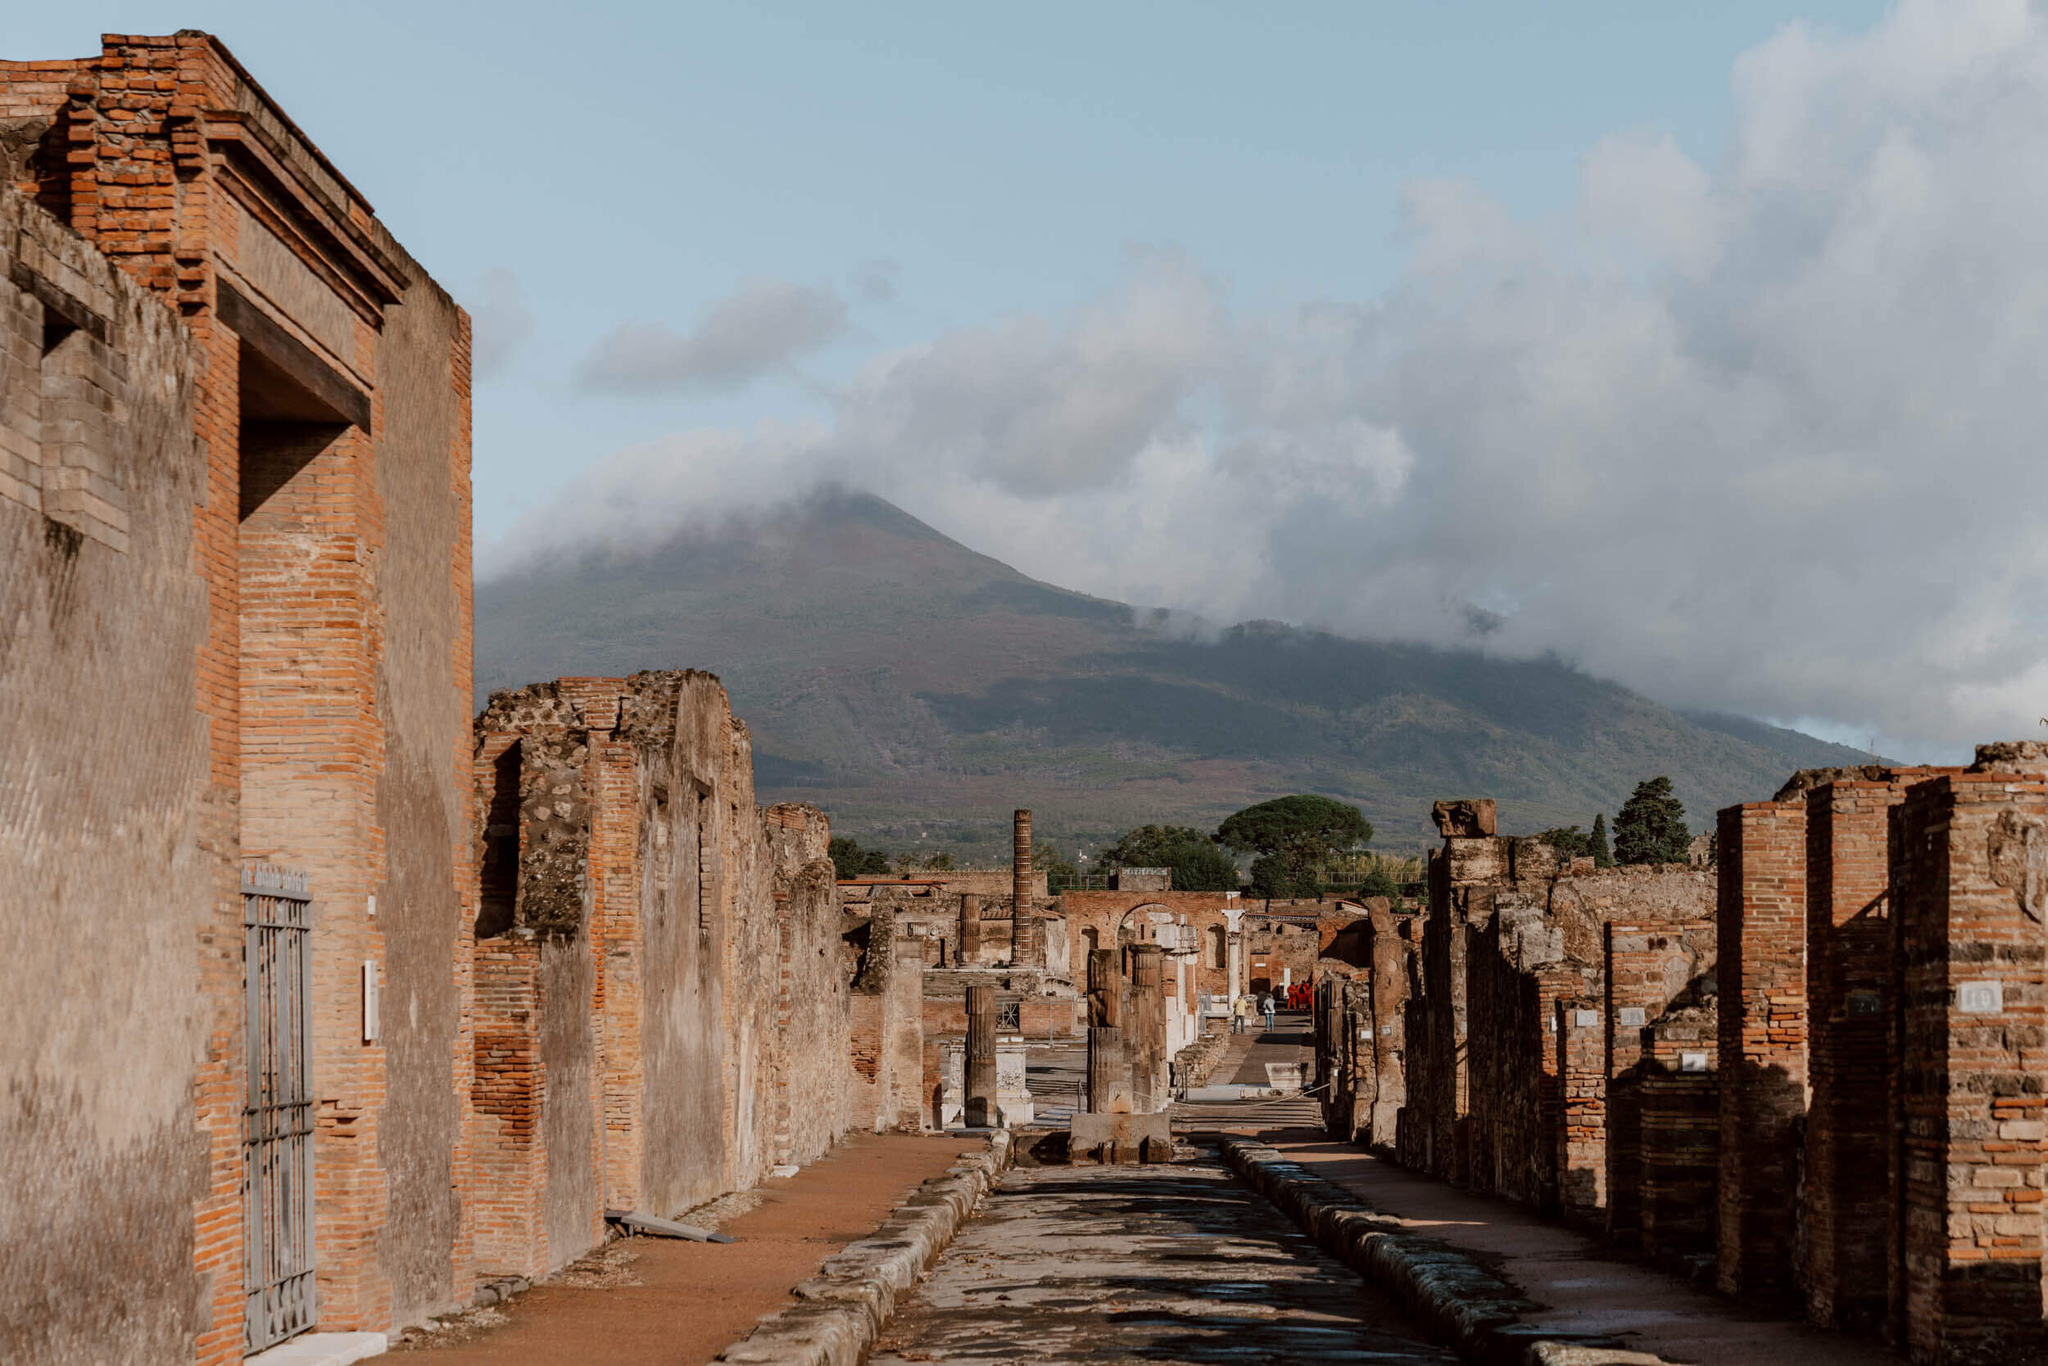Explain the visual content of the image in great detail. The photograph beautifully captures a historical scene from the ancient city of Pompeii, located in Italy. In the foreground, a cobblestone street flanked by timeworn brick structures extends towards the horizon. These once-vibrant buildings, now in ruins, still stand tall with their red and orange hues, hinting at the volcanic materials used in their construction. The decay and weathering of the structures tell tales of their antiquity and endurance.

In the backdrop, the majestic Mount Vesuvius rises imposingly, its peak shrouded in a thick blanket of clouds. This infamous volcano, responsible for the catastrophic eruption in 79 AD that buried Pompeii in ash, looms as a silent but persistent reminder of nature's formidable power. The clear blue sky above provides a stark contrast to the dark, brooding form of the volcano.

The image, despite the ravages of time, preserves a clear sense of the ancient city's layout, shedding light on the urban planning and architectural ingenuity of the Roman Empire. The scenery creates a powerful juxtaposition between the remnants of human civilization and the ever-present might of natural forces, capturing a poignant moment in history frozen forever in the passage of time. 